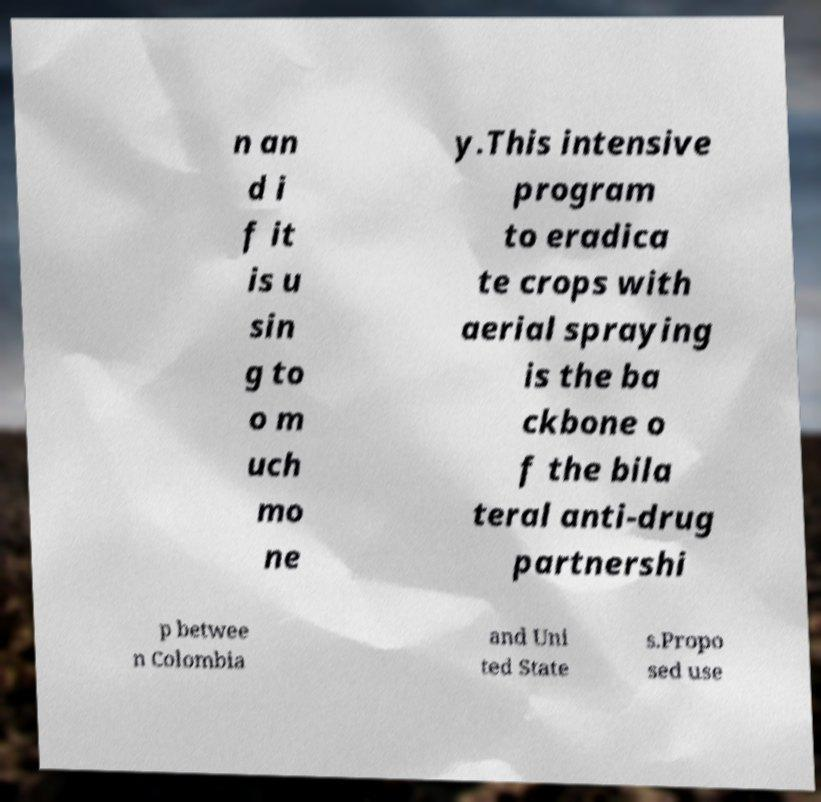For documentation purposes, I need the text within this image transcribed. Could you provide that? n an d i f it is u sin g to o m uch mo ne y.This intensive program to eradica te crops with aerial spraying is the ba ckbone o f the bila teral anti-drug partnershi p betwee n Colombia and Uni ted State s.Propo sed use 